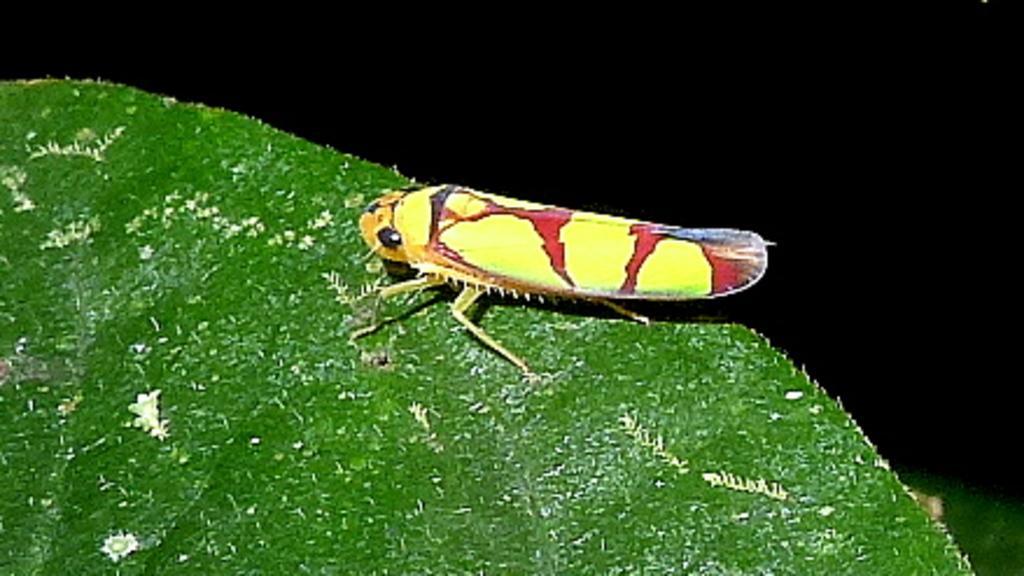In one or two sentences, can you explain what this image depicts? In this picture, we see an insect which looks like a grasshopper is on the green leaf. This insect is in yellow and red color. In the background, it is black in color. 